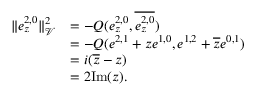Convert formula to latex. <formula><loc_0><loc_0><loc_500><loc_500>\begin{array} { r l } { \| e _ { z } ^ { 2 , 0 } \| _ { \mathcal { V } } ^ { 2 } } & { = - Q ( e _ { z } ^ { 2 , 0 } , \overline { { e _ { z } ^ { 2 , 0 } } } ) } \\ & { = - Q ( e ^ { 2 , 1 } + z e ^ { 1 , 0 } , e ^ { 1 , 2 } + \overline { z } e ^ { 0 , 1 } ) } \\ & { = i ( \overline { z } - z ) } \\ & { = 2 I m ( z ) . } \end{array}</formula> 